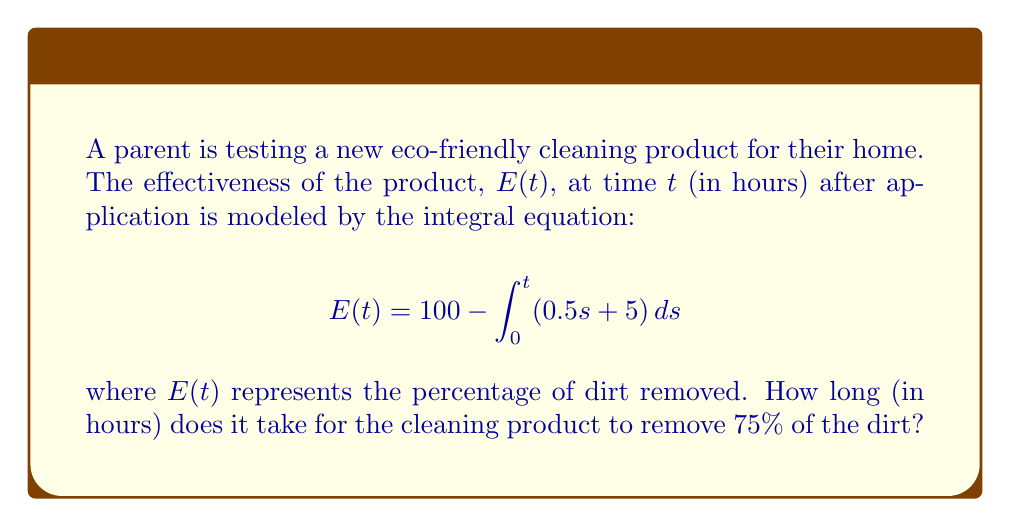Could you help me with this problem? To solve this problem, we need to follow these steps:

1) First, let's evaluate the integral in the equation:

   $$\int_0^t (0.5s + 5) ds = [0.25s^2 + 5s]_0^t = 0.25t^2 + 5t$$

2) Now, we can rewrite our equation:

   $$E(t) = 100 - (0.25t^2 + 5t)$$

3) We want to find when $E(t) = 75$, so let's set up this equation:

   $$75 = 100 - (0.25t^2 + 5t)$$

4) Simplify:

   $$0.25t^2 + 5t + 25 = 0$$

5) This is a quadratic equation. We can solve it using the quadratic formula:

   $$t = \frac{-b \pm \sqrt{b^2 - 4ac}}{2a}$$

   where $a = 0.25$, $b = 5$, and $c = 25$

6) Plugging in these values:

   $$t = \frac{-5 \pm \sqrt{25 - 25}}{0.5} = \frac{-5 \pm 0}{0.5} = -10$$

7) Since time cannot be negative, we only consider the positive solution:

   $$t = 10$$

Therefore, it takes 10 hours for the cleaning product to remove 75% of the dirt.
Answer: 10 hours 